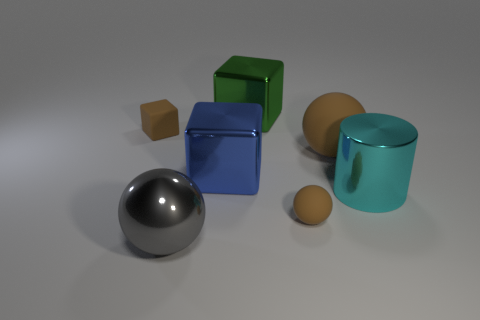Can you infer any possible functions for these objects based on their shapes and materials? While we can speculate based on their shapes and materials, without additional context it's challenging to infer definitive functions for these objects. The sphere and ovoid shapes may be decorative or part of a set of geometric models for display or education. The cube could be a container if hollow, or simply another geometric model. The translucent cylinder might be a container or a decorative piece. The cyan object, if hollow, could be a utensil holder or decorative vase, as its reflective surface gives it an aesthetic quality. 